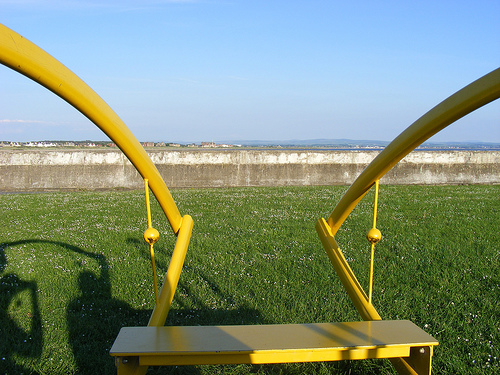<image>
Can you confirm if the rod is next to the rope? Yes. The rod is positioned adjacent to the rope, located nearby in the same general area. 